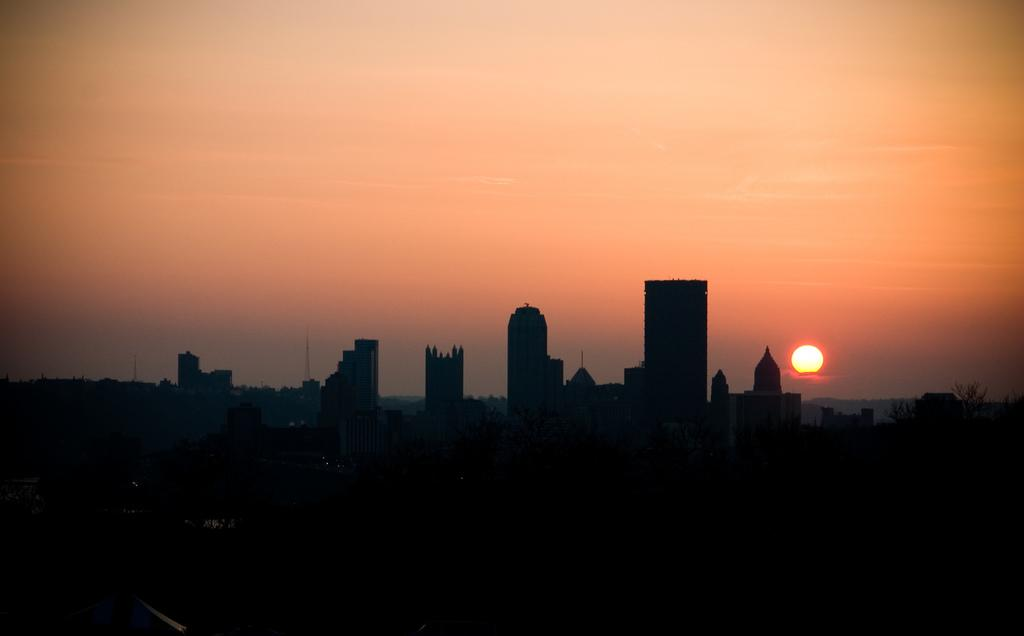What type of structures can be seen in the image? There are buildings in the image. What other natural elements are present in the image? There are trees in the image. What can be seen in the background of the image? The sky is visible in the background of the image. Is there a celestial body visible in the sky? Yes, the sun is observable in the sky. How would you describe the overall lighting in the image? The image appears to be dark. What type of boats can be seen in the image? There are no boats present in the image. What color is the paint on the trees in the image? The image does not depict any paint on the trees, as trees are naturally green or brown. 